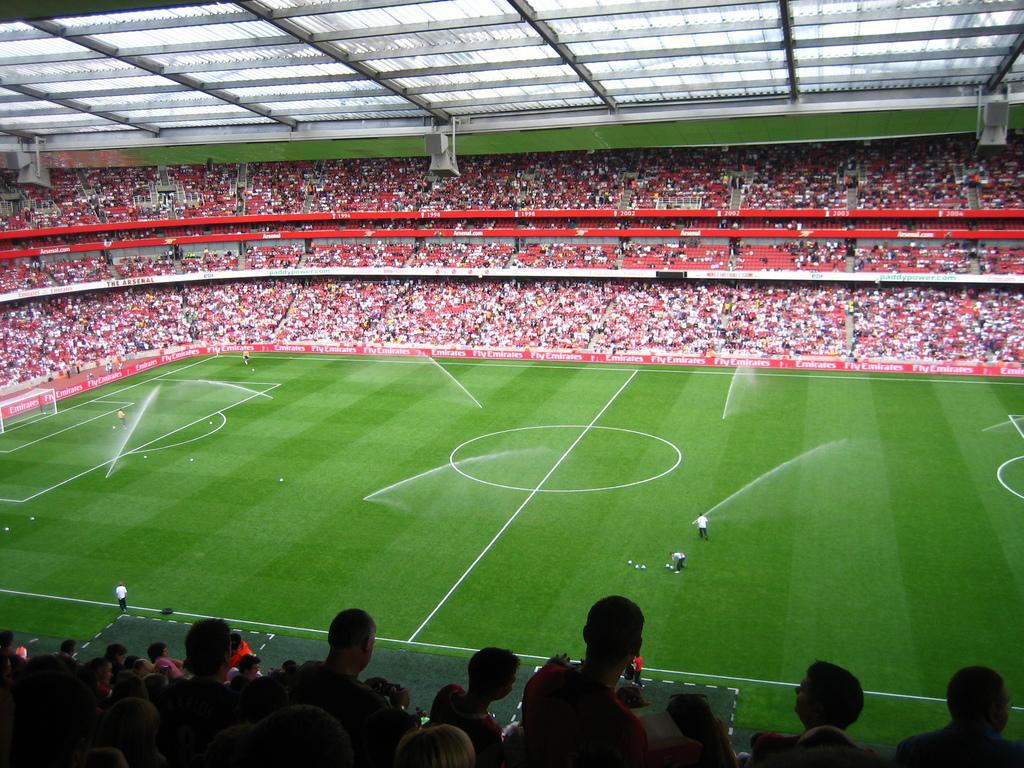In one or two sentences, can you explain what this image depicts? This picture looks like a stadium, we can see a few people, among them some people are on the ground and some people are sitting on the chairs, we can see some balls on the ground, at the top we can see some metal rods. 